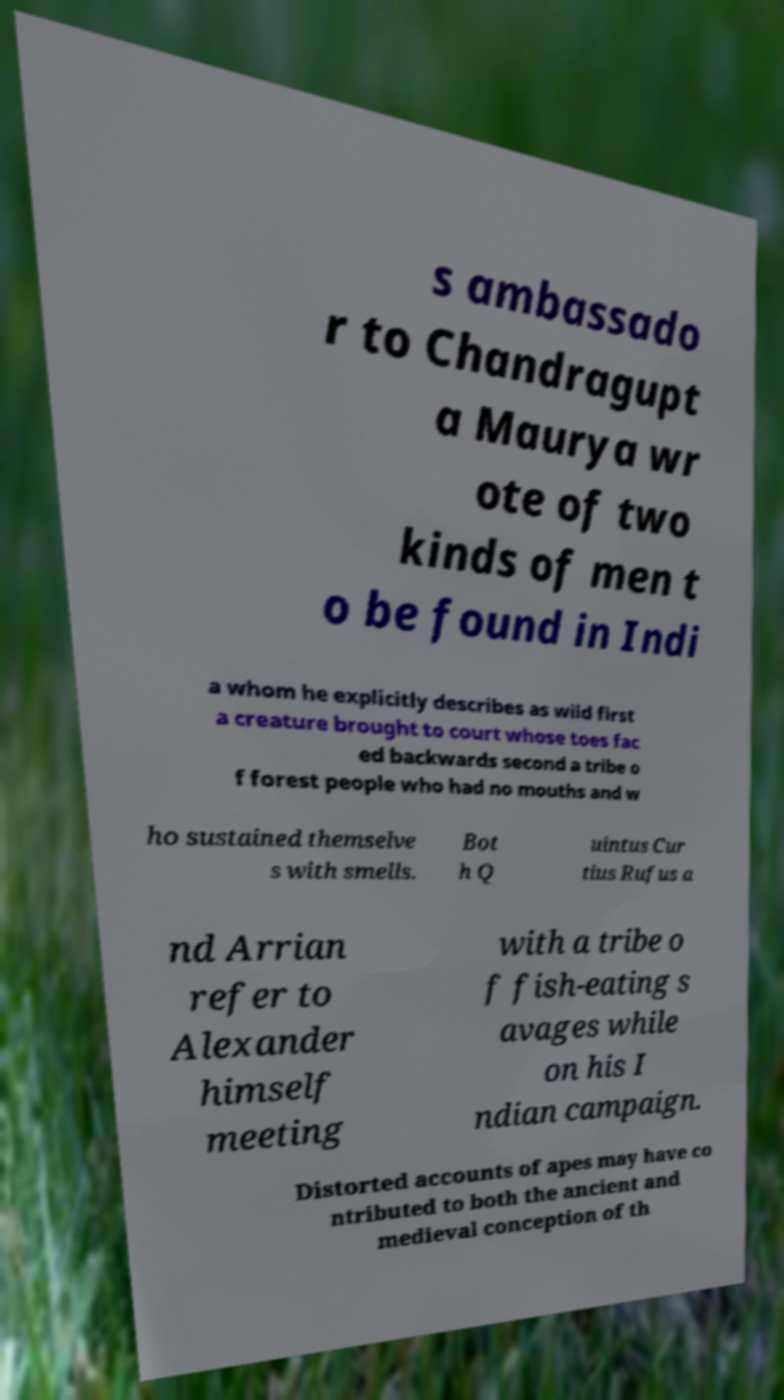There's text embedded in this image that I need extracted. Can you transcribe it verbatim? s ambassado r to Chandragupt a Maurya wr ote of two kinds of men t o be found in Indi a whom he explicitly describes as wild first a creature brought to court whose toes fac ed backwards second a tribe o f forest people who had no mouths and w ho sustained themselve s with smells. Bot h Q uintus Cur tius Rufus a nd Arrian refer to Alexander himself meeting with a tribe o f fish-eating s avages while on his I ndian campaign. Distorted accounts of apes may have co ntributed to both the ancient and medieval conception of th 